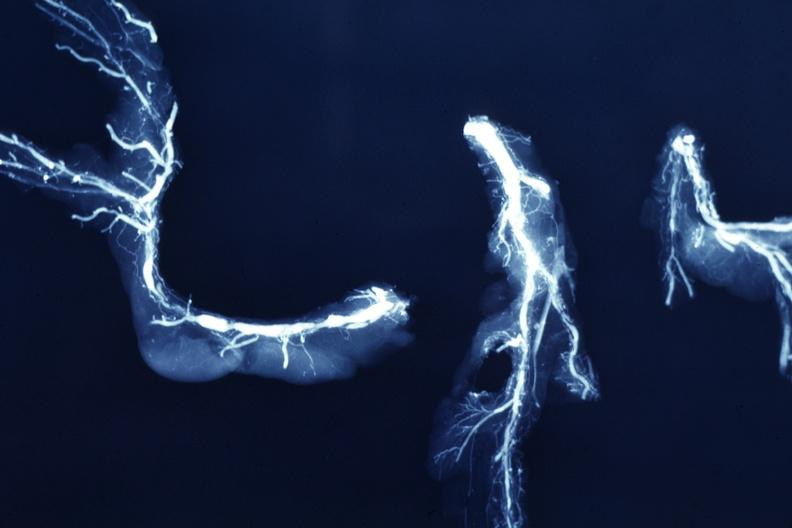s cardiovascular present?
Answer the question using a single word or phrase. Yes 